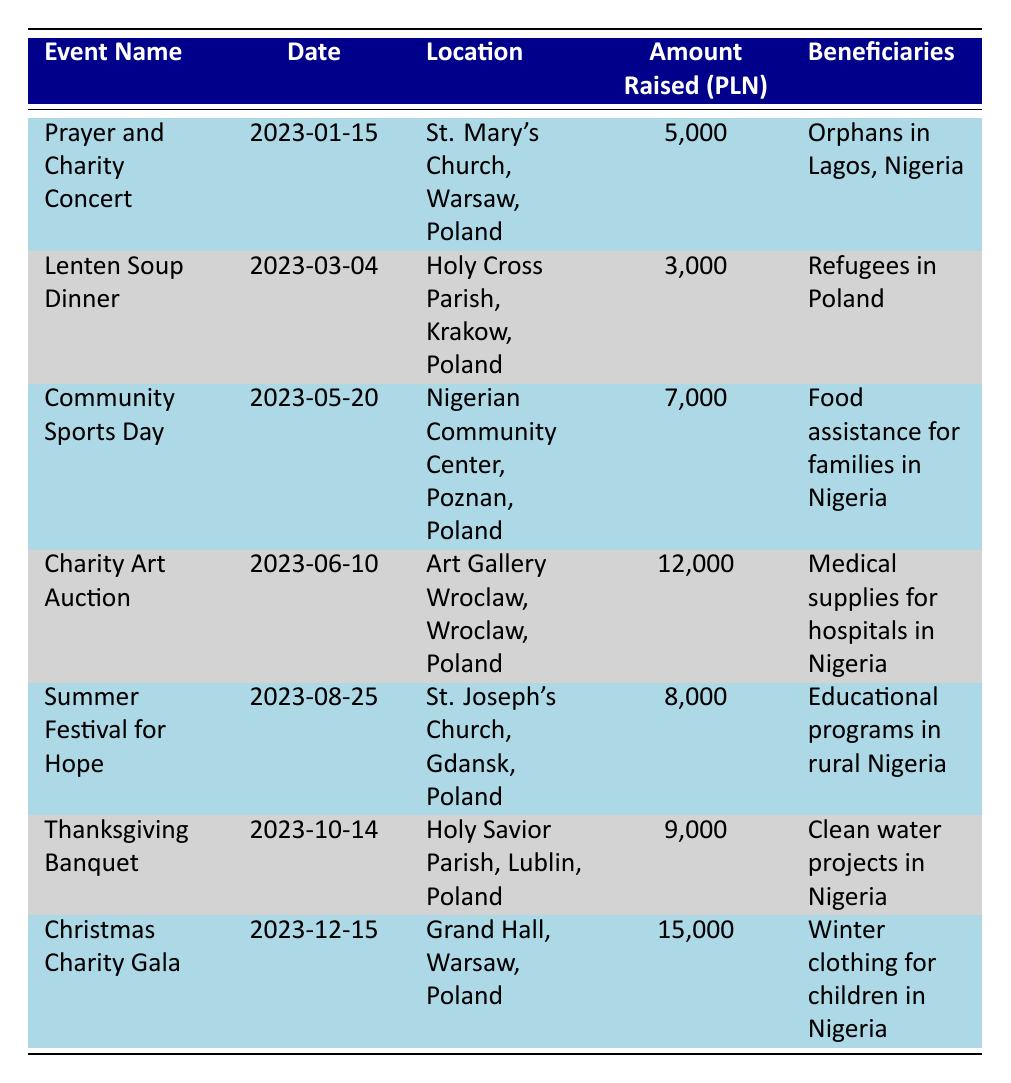What event raised the most money in 2023? Looking through the table, the event "Christmas Charity Gala" raised the most money at 15,000 PLN compared to other events.
Answer: Christmas Charity Gala How much was raised in total from all fundraising events? To find the total amount raised, add up the amounts from all events: 5,000 + 3,000 + 7,000 + 12,000 + 8,000 + 9,000 + 15,000 = 59,000 PLN.
Answer: 59,000 PLN Did the "Lenten Soup Dinner" raise more than the "Prayer and Charity Concert"? The "Lenten Soup Dinner" raised 3,000 PLN, while the "Prayer and Charity Concert" raised 5,000 PLN. Since 3,000 is not greater than 5,000, the answer is no.
Answer: No Which event specifically benefited medical supplies for hospitals? Referring to the table, the "Charity Art Auction" is noted as the event that benefited medical supplies for hospitals in Nigeria.
Answer: Charity Art Auction What is the average amount raised per event? To calculate the average, first sum the total amount raised (59,000 PLN) and divide it by the number of events (7). The calculation is 59,000 / 7 = 8,428.57 PLN, thus the average raised per event is approximately 8,429 PLN.
Answer: 8,429 PLN Is it true that more money was raised in the second half of the year compared to the first half? Adding the amounts raised for the first half-year events gives: 5,000 + 3,000 + 7,000 + 12,000 = 27,000 PLN. For the second half: 8,000 + 9,000 + 15,000 = 32,000 PLN. Since 32,000 is greater than 27,000, the answer is yes.
Answer: Yes What location hosted the "Summer Festival for Hope"? The table provides that the "Summer Festival for Hope" was held at St. Joseph’s Church in Gdansk, Poland.
Answer: St. Joseph’s Church, Gdansk, Poland Which event occurred last in the year? By reviewing the dates provided in the table, the "Christmas Charity Gala" on December 15, 2023, is the last event of the year.
Answer: Christmas Charity Gala 